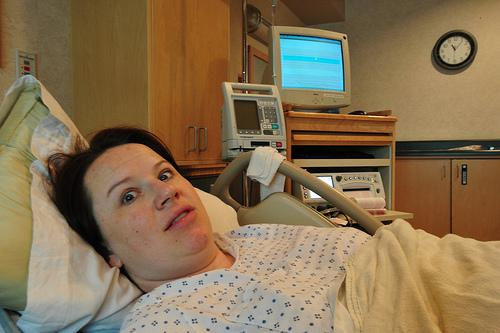Question: where was this taken?
Choices:
A. In a doctor's office.
B. In a hospital room.
C. In a gift shop.
D. In a therapists office.
Answer with the letter. Answer: B Question: what is the woman doing?
Choices:
A. Sleeping.
B. Lying in a hospital bed.
C. Receiving treatment.
D. Reading a magazine.
Answer with the letter. Answer: B Question: who is lying in the bed?
Choices:
A. The man.
B. The woman.
C. The child.
D. The cat.
Answer with the letter. Answer: B Question: how many pieces of medical equipment are there?
Choices:
A. Six.
B. Seven.
C. Eight.
D. Three.
Answer with the letter. Answer: D Question: what is on the wall?
Choices:
A. A painting.
B. A frame.
C. A light.
D. A clock.
Answer with the letter. Answer: D 